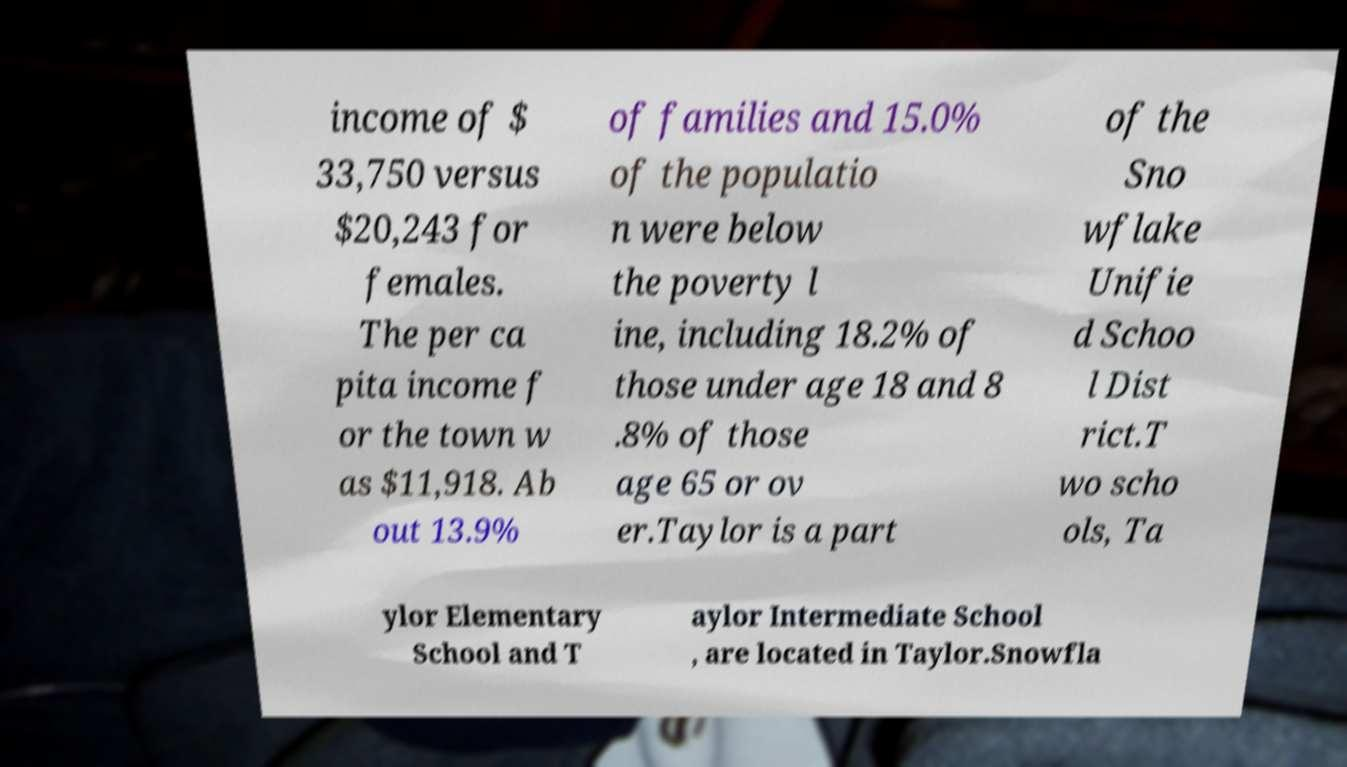Please identify and transcribe the text found in this image. income of $ 33,750 versus $20,243 for females. The per ca pita income f or the town w as $11,918. Ab out 13.9% of families and 15.0% of the populatio n were below the poverty l ine, including 18.2% of those under age 18 and 8 .8% of those age 65 or ov er.Taylor is a part of the Sno wflake Unifie d Schoo l Dist rict.T wo scho ols, Ta ylor Elementary School and T aylor Intermediate School , are located in Taylor.Snowfla 